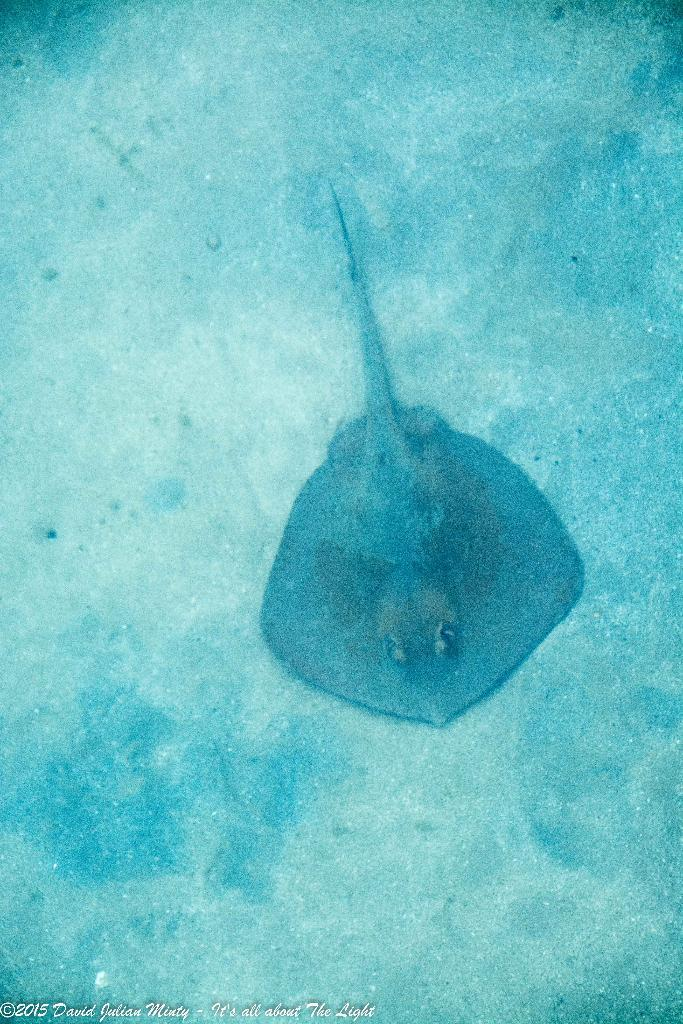What type of sea creature is in the image? There is a whip-ray in the image. Where is the whip-ray located in the image? The whip-ray is on the ground underwater in the image. What type of wax can be seen melting in the image? There is no wax present in the image; it features a whip-ray underwater. 